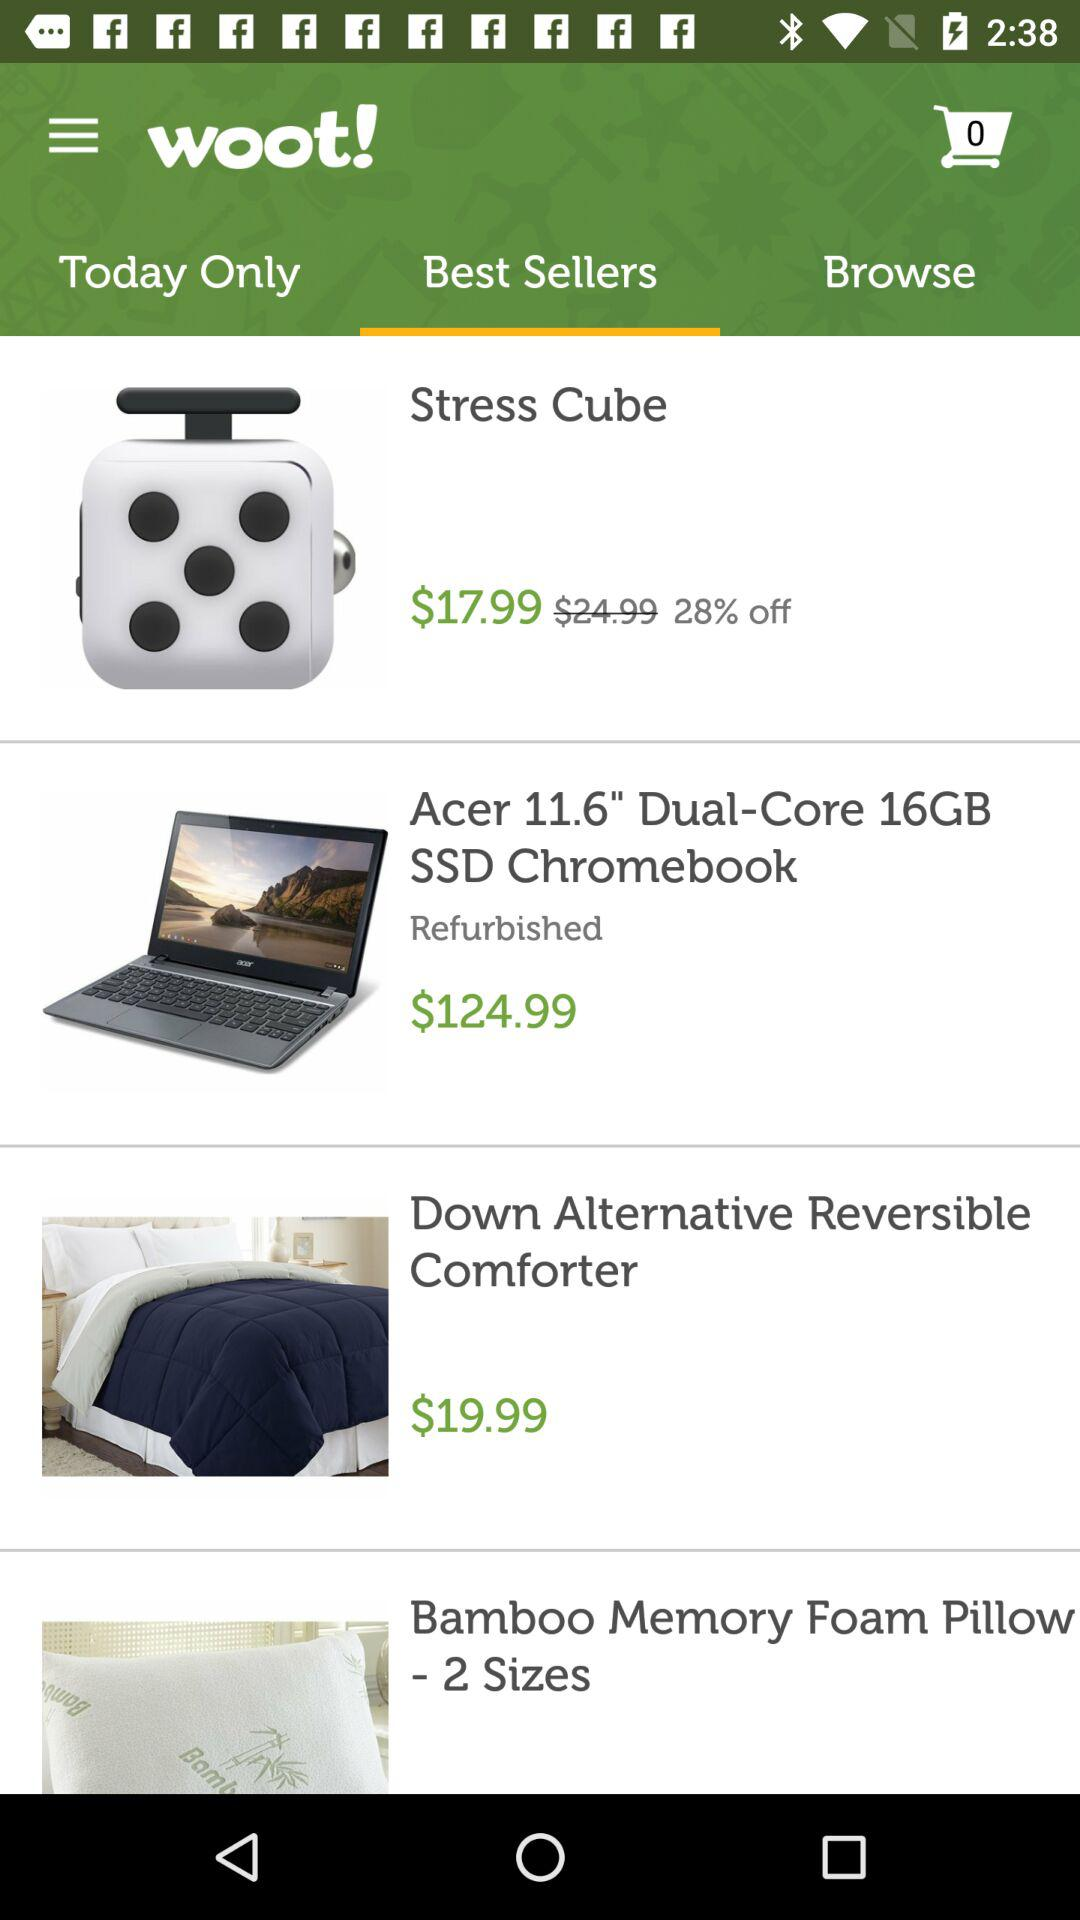What is the discount on "Stress Cube"? The discount on "Stress Cube" is 28%. 